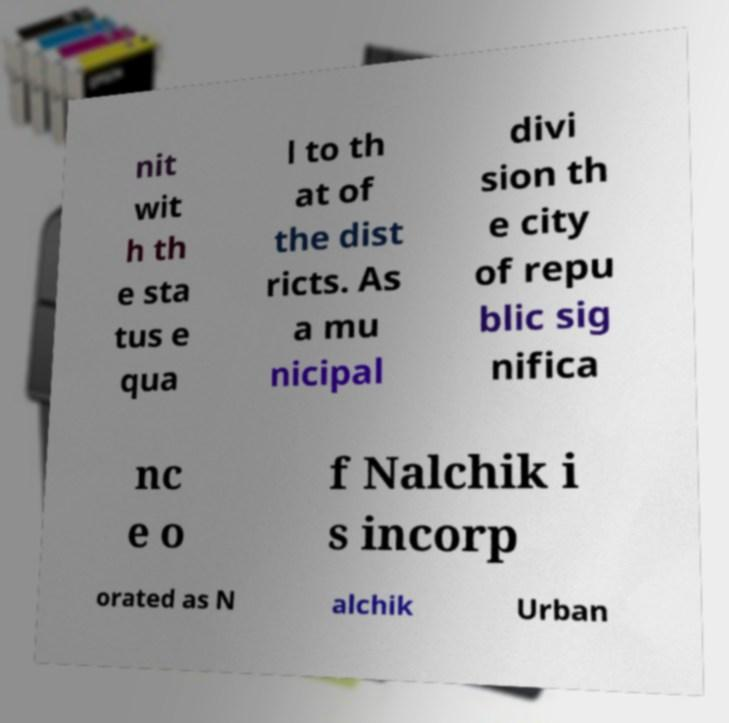There's text embedded in this image that I need extracted. Can you transcribe it verbatim? nit wit h th e sta tus e qua l to th at of the dist ricts. As a mu nicipal divi sion th e city of repu blic sig nifica nc e o f Nalchik i s incorp orated as N alchik Urban 